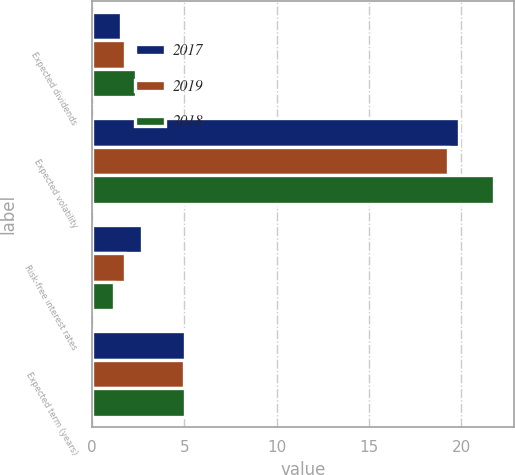Convert chart to OTSL. <chart><loc_0><loc_0><loc_500><loc_500><stacked_bar_chart><ecel><fcel>Expected dividends<fcel>Expected volatility<fcel>Risk-free interest rates<fcel>Expected term (years)<nl><fcel>2017<fcel>1.6<fcel>19.9<fcel>2.7<fcel>5.03<nl><fcel>2019<fcel>1.8<fcel>19.3<fcel>1.8<fcel>5<nl><fcel>2018<fcel>2.4<fcel>21.8<fcel>1.2<fcel>5.03<nl></chart> 